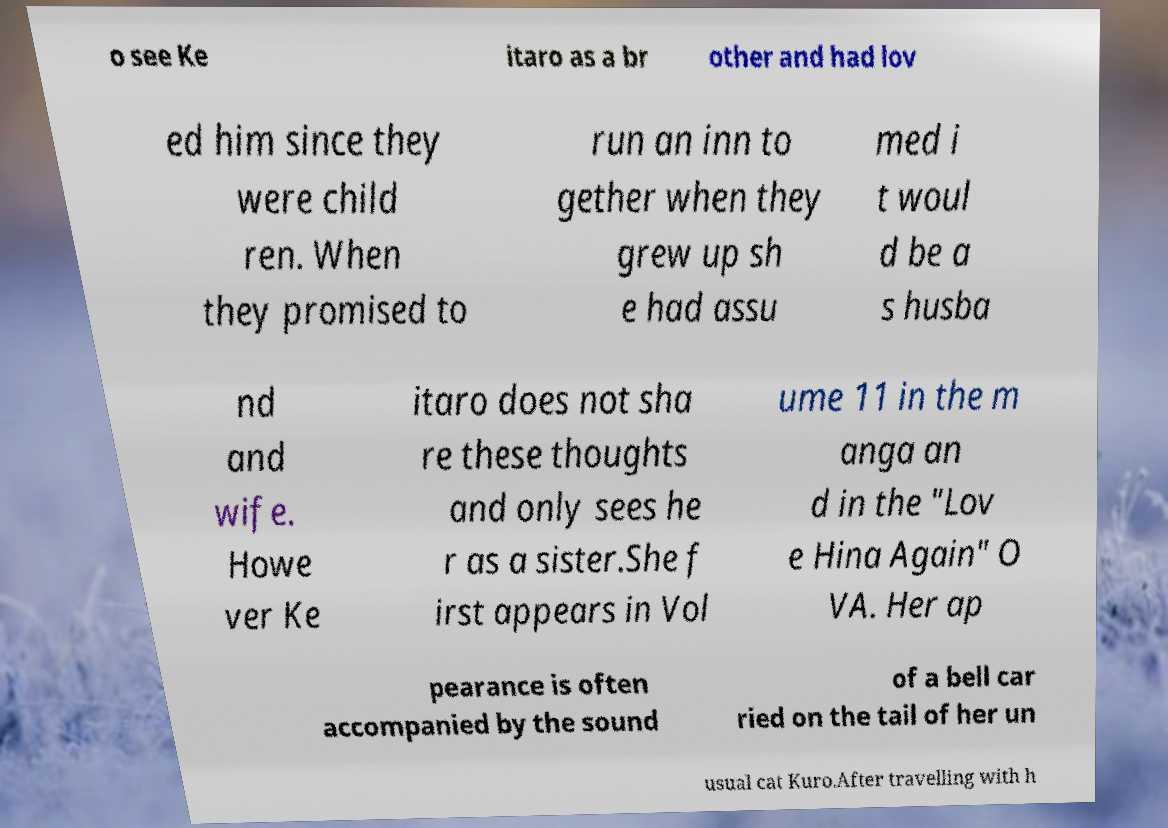Could you extract and type out the text from this image? o see Ke itaro as a br other and had lov ed him since they were child ren. When they promised to run an inn to gether when they grew up sh e had assu med i t woul d be a s husba nd and wife. Howe ver Ke itaro does not sha re these thoughts and only sees he r as a sister.She f irst appears in Vol ume 11 in the m anga an d in the "Lov e Hina Again" O VA. Her ap pearance is often accompanied by the sound of a bell car ried on the tail of her un usual cat Kuro.After travelling with h 